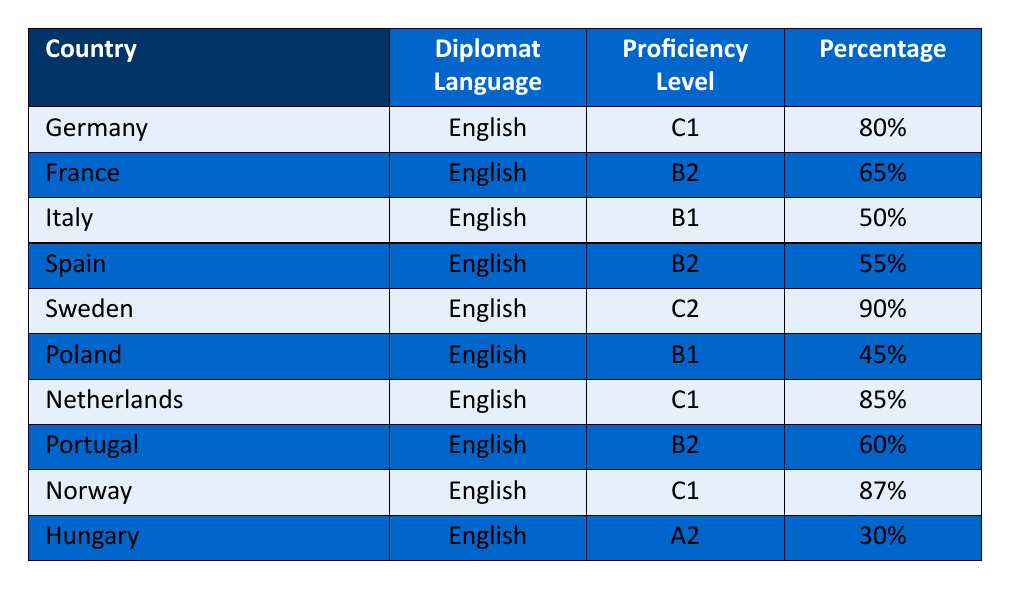What is the highest language proficiency level reported among diplomats? The table shows that the highest proficiency level is C2, which is marked for Sweden with 90% proficiency.
Answer: C2 Which country's diplomats have a proficiency level of B1? In the table, Italy and Poland are both listed with a proficiency level of B1.
Answer: Italy and Poland What percentage of diplomats from France have a proficiency level of at least B2? The table indicates that France has 65% of diplomats at B2, which are included in the "at least B2" category.
Answer: 65% How many countries have diplomats with a proficiency level of C1 or higher? According to the data, Germany, Sweden, Netherlands, and Norway have proficiency levels of C1 or higher, totaling four countries.
Answer: Four Is there any country where diplomats have a proficiency level lower than B1? Yes, Hungary has a proficiency level of A2, which is lower than B1.
Answer: Yes What is the average proficiency percentage for diplomats with the proficiency level B2? To calculate the average for countries with B2 (France, Spain, Portugal), we sum 65%, 55%, and 60%, which equals 180%. Dividing by three (the number of countries) gives an average of 60%.
Answer: 60% Which country has the highest percentage of diplomats at a C1 proficiency level? From the table, Norway has the highest percentage at 87%, followed closely by the Netherlands at 85%.
Answer: Norway What is the difference between the highest and lowest percentage of proficiency reported? The highest proficiency is 90% from Sweden and the lowest is 30% from Hungary. The difference is 90% - 30% = 60%.
Answer: 60% 